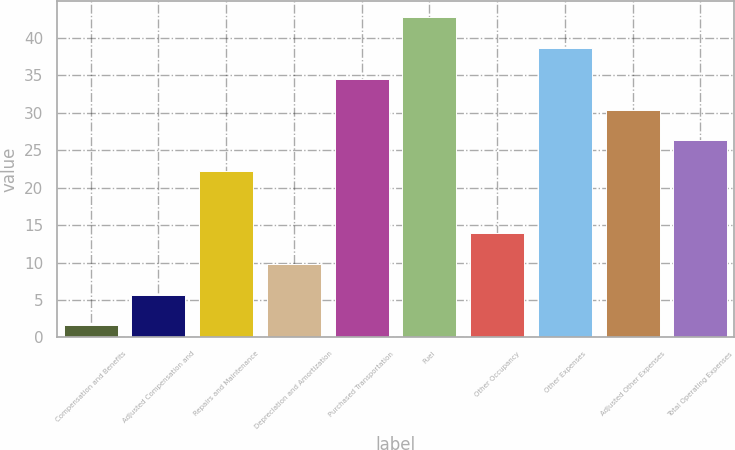Convert chart to OTSL. <chart><loc_0><loc_0><loc_500><loc_500><bar_chart><fcel>Compensation and Benefits<fcel>Adjusted Compensation and<fcel>Repairs and Maintenance<fcel>Depreciation and Amortization<fcel>Purchased Transportation<fcel>Fuel<fcel>Other Occupancy<fcel>Other Expenses<fcel>Adjusted Other Expenses<fcel>Total Operating Expenses<nl><fcel>1.6<fcel>5.72<fcel>22.2<fcel>9.84<fcel>34.56<fcel>42.8<fcel>13.96<fcel>38.68<fcel>30.44<fcel>26.32<nl></chart> 